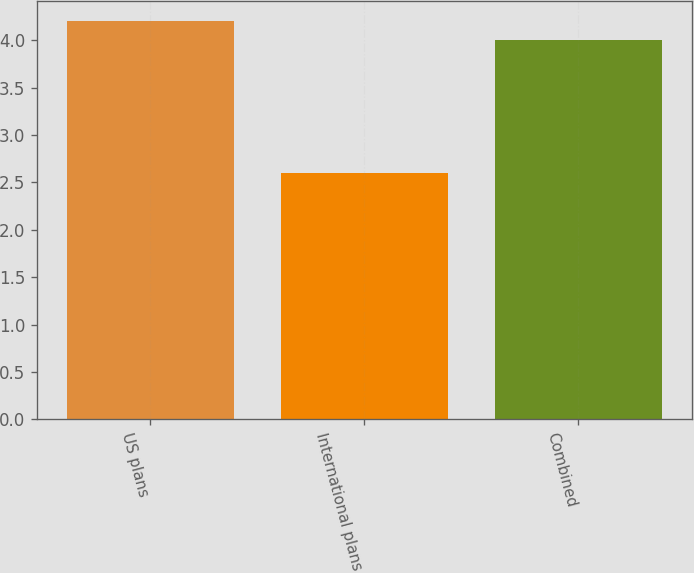<chart> <loc_0><loc_0><loc_500><loc_500><bar_chart><fcel>US plans<fcel>International plans<fcel>Combined<nl><fcel>4.2<fcel>2.6<fcel>4<nl></chart> 